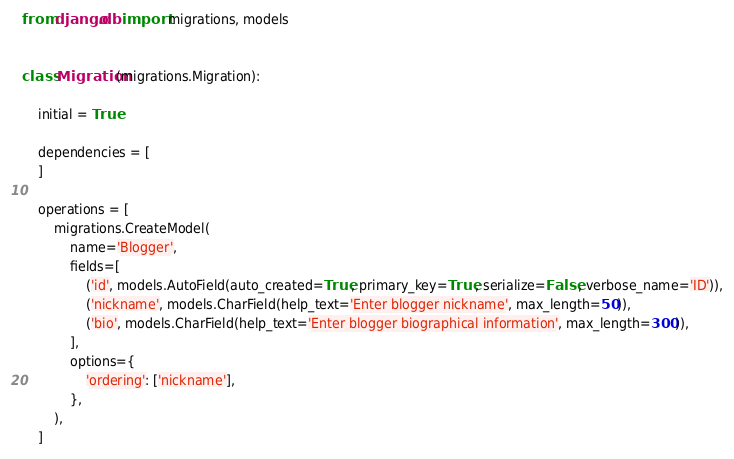Convert code to text. <code><loc_0><loc_0><loc_500><loc_500><_Python_>
from django.db import migrations, models


class Migration(migrations.Migration):

    initial = True

    dependencies = [
    ]

    operations = [
        migrations.CreateModel(
            name='Blogger',
            fields=[
                ('id', models.AutoField(auto_created=True, primary_key=True, serialize=False, verbose_name='ID')),
                ('nickname', models.CharField(help_text='Enter blogger nickname', max_length=50)),
                ('bio', models.CharField(help_text='Enter blogger biographical information', max_length=300)),
            ],
            options={
                'ordering': ['nickname'],
            },
        ),
    ]
</code> 